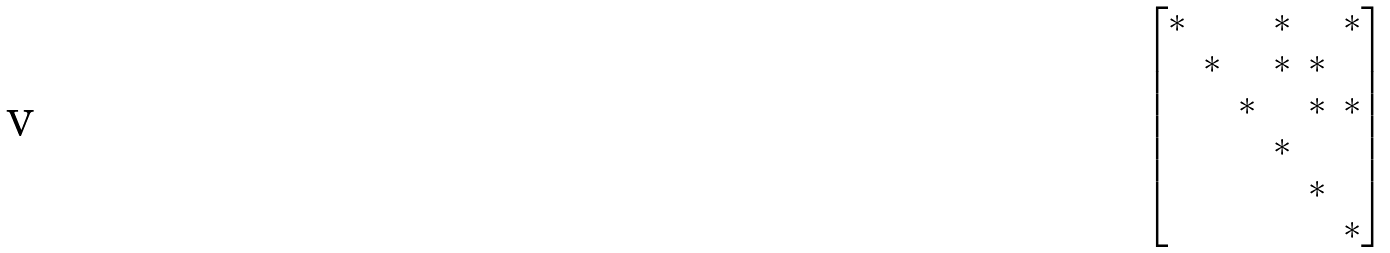<formula> <loc_0><loc_0><loc_500><loc_500>\begin{bmatrix} * & & & * & & * \\ & * & & * & * \\ & & * & & * & * \\ & & & * \\ & & & & * \\ & & & & & * \end{bmatrix}</formula> 